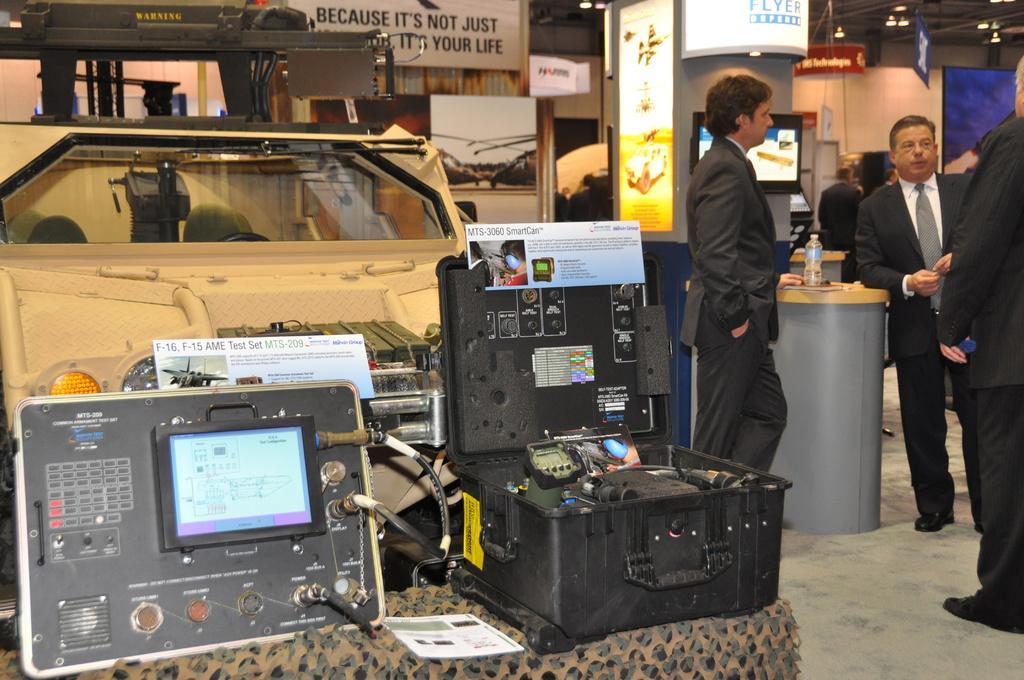How would you summarize this image in a sentence or two? Here we can see few persons standing on the floor. There are devices, cloth, boards, screen, bottle, and lights. In the background we can see wall. 